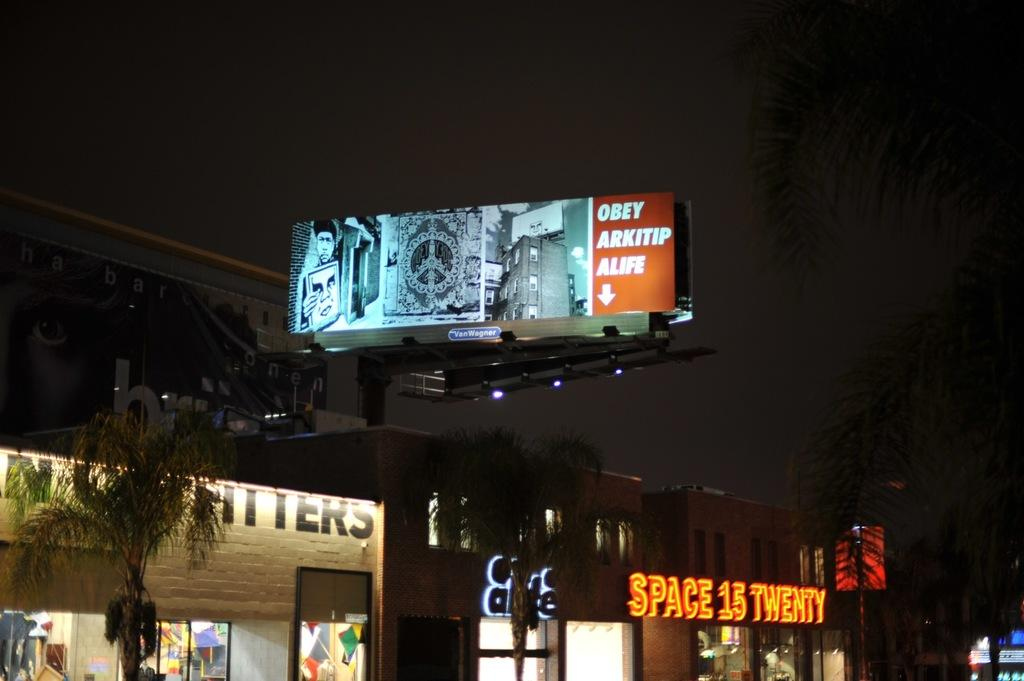Provide a one-sentence caption for the provided image. Billboard that says Obey Arkitip Alife with a arrow pointing down below. 